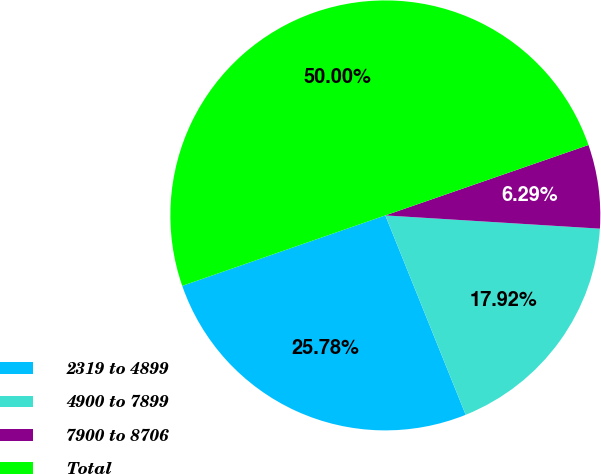Convert chart to OTSL. <chart><loc_0><loc_0><loc_500><loc_500><pie_chart><fcel>2319 to 4899<fcel>4900 to 7899<fcel>7900 to 8706<fcel>Total<nl><fcel>25.78%<fcel>17.92%<fcel>6.29%<fcel>50.0%<nl></chart> 